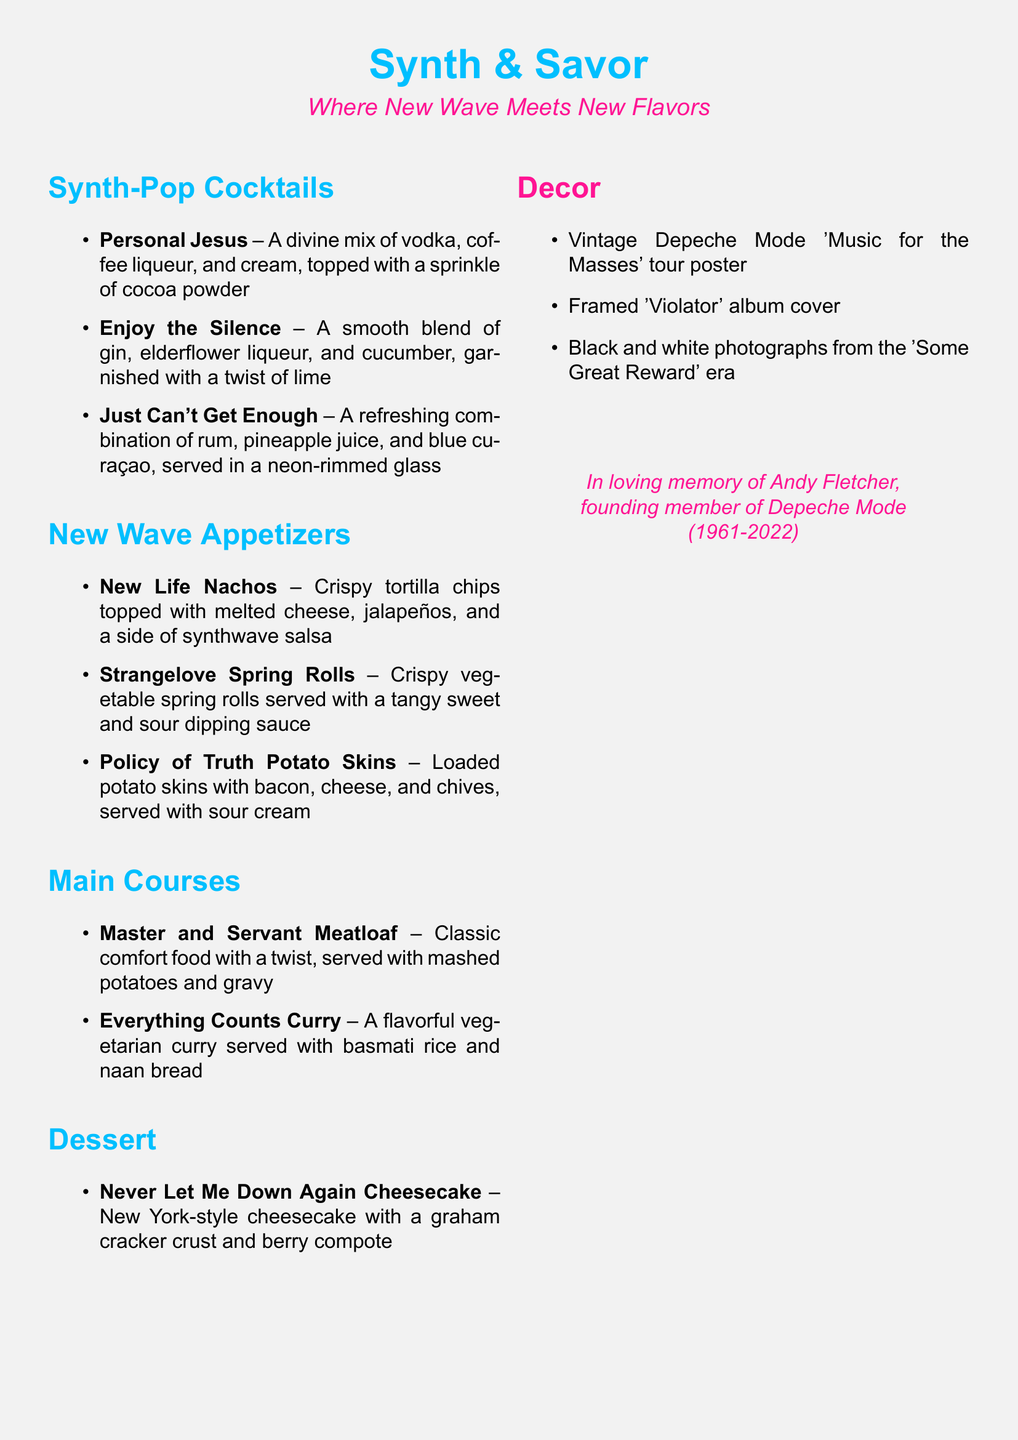What is the name of the restaurant? The name of the restaurant is prominently displayed at the top of the menu document.
Answer: Synth & Savor What color is used for the section titles? The section titles in the menu are styled using a specific color noted in the document.
Answer: Synth blue What type of cocktail is "Enjoy the Silence"? The menu describes each cocktail and provides details about their ingredients.
Answer: Gin cocktail Which appetizer is loaded with bacon? The document lists appetizers, including one notable for its ingredients.
Answer: Policy of Truth Potato Skins How many main courses are listed on the menu? The document specifies the main course section and counts the items listed.
Answer: Two What vintage item decorates the restaurant? There are several types of decorations mentioned, showcasing the nostalgia theme.
Answer: Tour poster What is the name of the dessert? The section on desserts names a specific dessert featured in the menu.
Answer: Never Let Me Down Again Cheesecake In memory of whom is the restaurant dedicated? The document includes a heartfelt tribute to a member of Depeche Mode.
Answer: Andy Fletcher What is the main ingredient in "Just Can't Get Enough" cocktail? Each cocktail includes key ingredients, one of which is highlighted in this cocktail.
Answer: Rum 